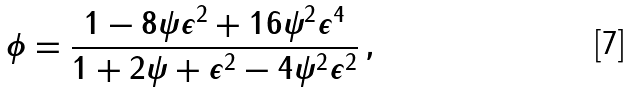Convert formula to latex. <formula><loc_0><loc_0><loc_500><loc_500>\phi = \frac { 1 - 8 \psi \epsilon ^ { 2 } + 1 6 \psi ^ { 2 } \epsilon ^ { 4 } } { 1 + 2 \psi + \epsilon ^ { 2 } - 4 \psi ^ { 2 } \epsilon ^ { 2 } } \, ,</formula> 